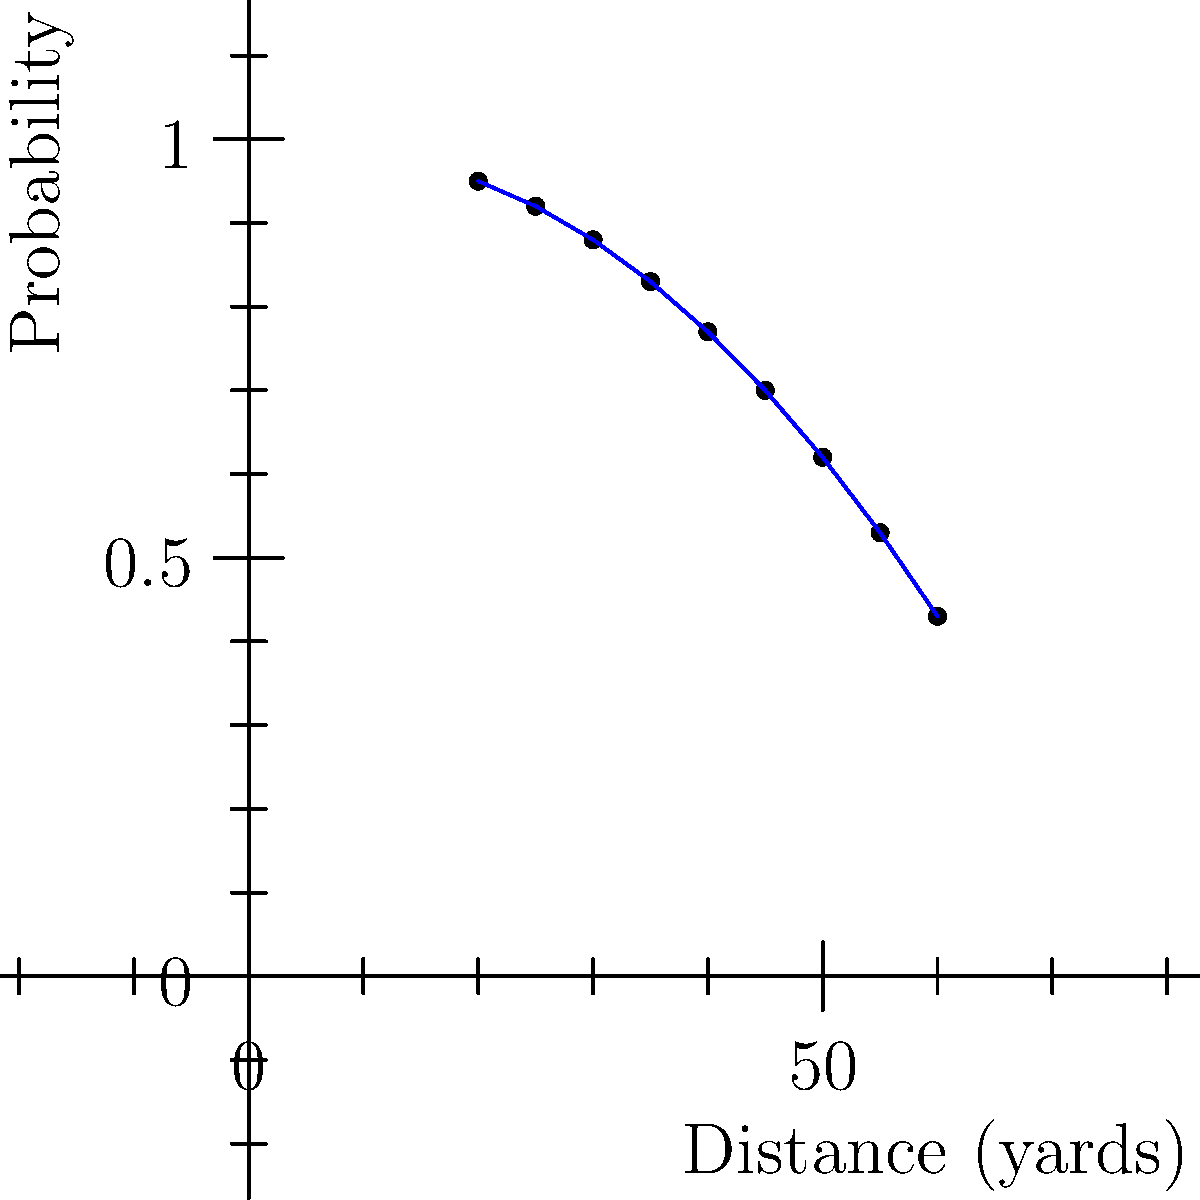As a football content creator, you're analyzing field goal probabilities. The scatter plot shows the relationship between field goal distance and success probability. If a team is facing a 4th down at their opponent's 35-yard line, what is the approximate probability of successfully kicking a field goal? How might this information influence a coach's decision-making? To answer this question, we need to follow these steps:

1. Understand the data representation:
   - The x-axis represents the field goal distance in yards.
   - The y-axis represents the probability of success.

2. Locate the relevant data point:
   - The team is at the opponent's 35-yard line.
   - A field goal attempt from this position would be approximately 52 yards (35 yards + 17 yards for the end zone and holder's position).

3. Estimate the probability:
   - Looking at the scatter plot, we need to find the point corresponding to 52 yards.
   - This falls between the 50-yard and 55-yard marks on the x-axis.
   - The corresponding probability appears to be around 0.58 or 58%.

4. Interpret the result:
   - The probability of successfully kicking a 52-yard field goal is approximately 58%.

5. Consider the decision-making implications:
   - With a 58% chance of success, the coach must weigh this against other options:
     a) Attempting to convert the 4th down
     b) Punting the ball

   - Factors to consider include:
     a) The current score and time remaining
     b) The team's offensive capabilities
     c) The opponent's defensive strengths
     d) Field position implications if the field goal is missed

   - A 58% success rate is relatively high for a long field goal, which might encourage the coach to attempt it, especially if:
     a) The team is trailing and needs points
     b) It's late in the game
     c) The potential field position loss is deemed acceptable

   However, if it's early in the game or the team is leading, the coach might opt for a more conservative approach and punt the ball to pin the opponent deep in their territory.
Answer: Approximately 58% probability; influences risk-reward analysis in decision-making. 